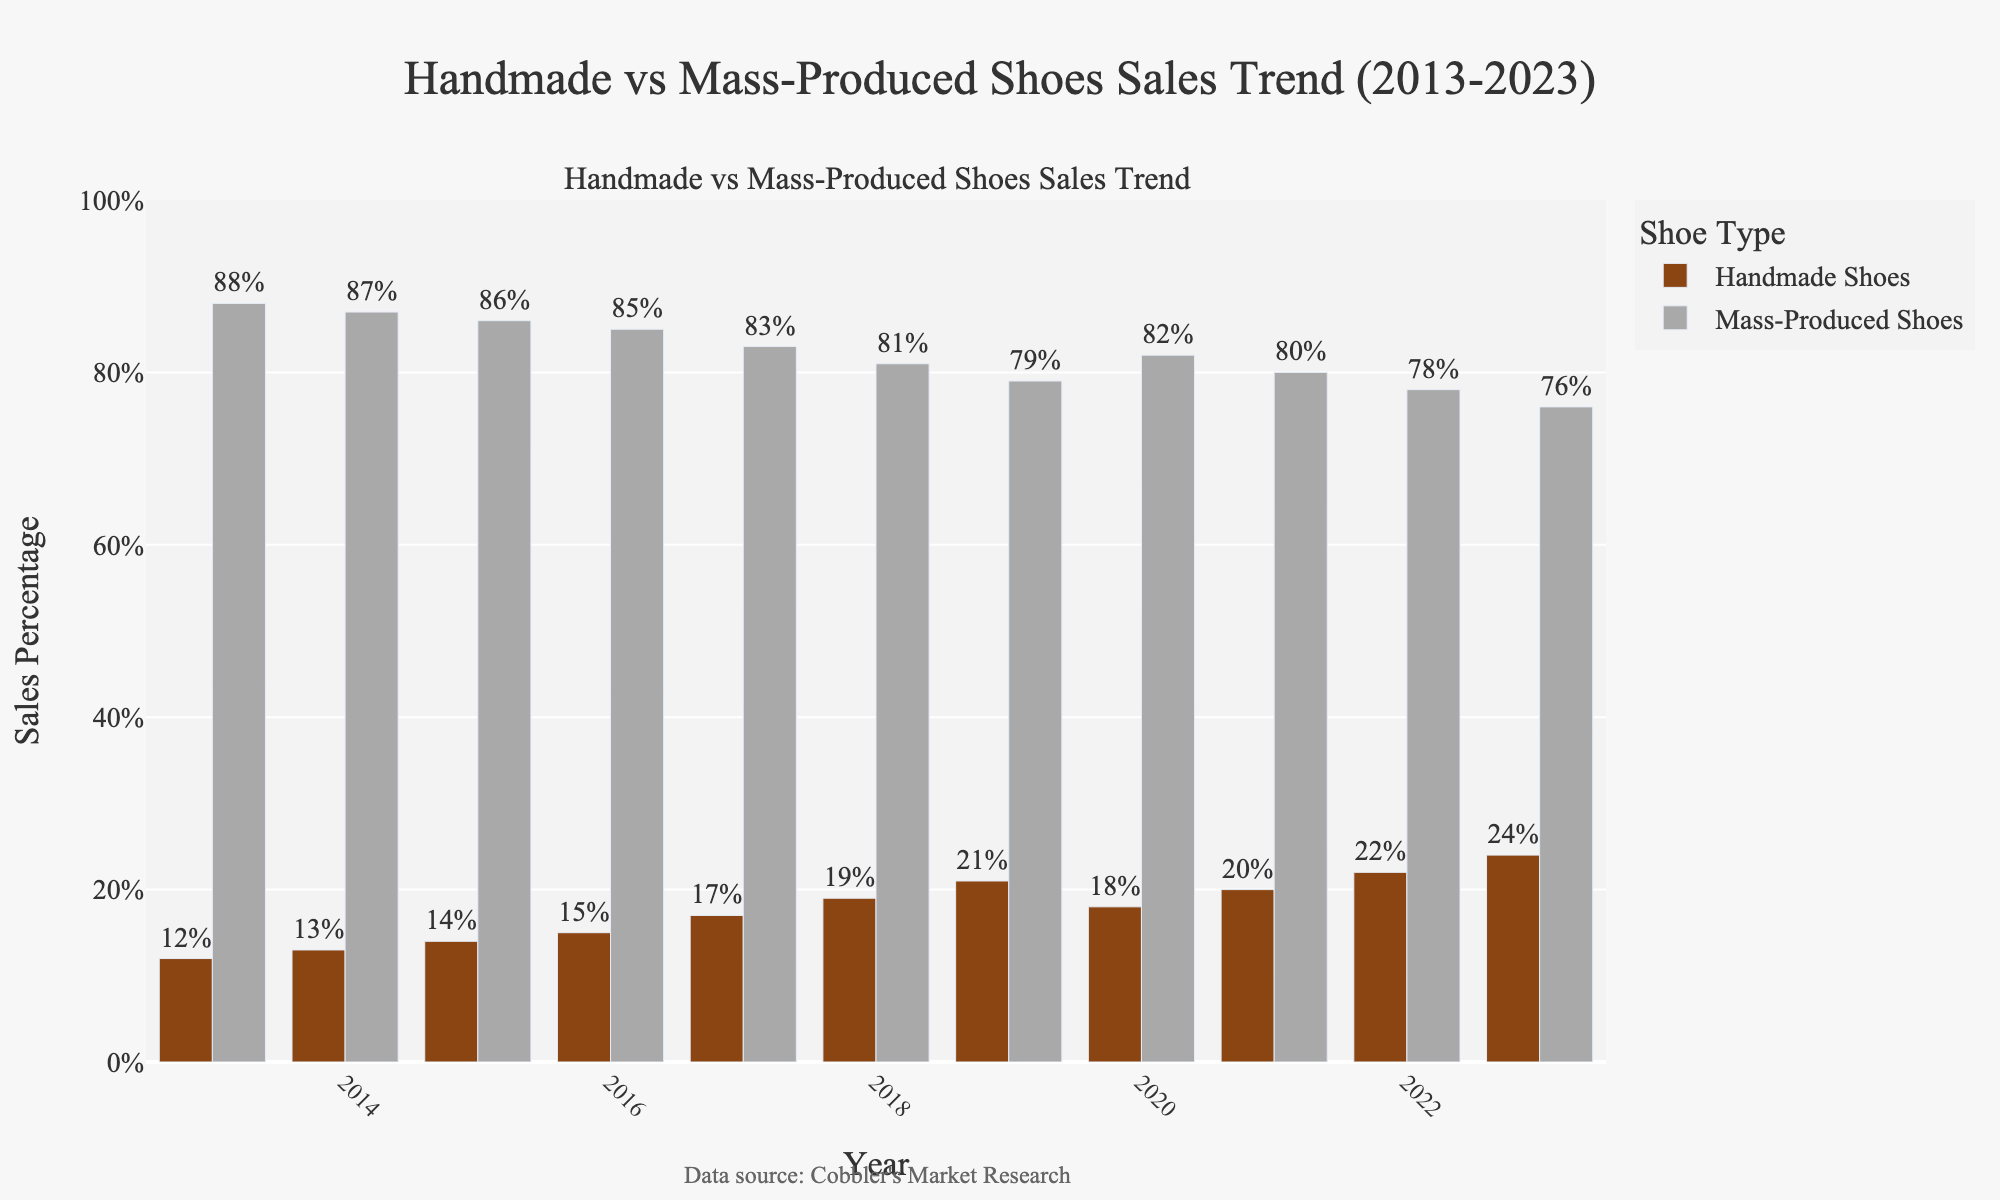Which type of shoes had the higher sales percentage in 2019? The bar representing Mass-Produced Shoes in 2019 is taller than the one for Handmade Shoes. Thus, Mass-Produced Shoes had a higher sales percentage in 2019.
Answer: Mass-Produced Shoes How much did the sales percentage of Handmade Shoes increase from 2013 to 2023? The sales percentage for Handmade Shoes was 12% in 2013 and increased to 24% in 2023. The increase is calculated as 24% - 12% = 12%.
Answer: 12% In which year did Handmade Shoes sales experience a drop? The Handmade Shoes sales dropped between 2019 and 2020 with values changing from 21% in 2019 to 18% in 2020.
Answer: 2020 What is the total sales percentage of both types of shoes in 2021? Adding the sales percentages of Handmade Shoes (20%) and Mass-Produced Shoes (80%) in 2021 results in 20% + 80% = 100%.
Answer: 100% By how many percentage points did the sales percentage of Mass-Produced Shoes decrease from 2013 to 2023? The sales percentage of Mass-Produced Shoes was 88% in 2013 and decreased to 76% in 2023. The decrease is calculated as 88% - 76% = 12%.
Answer: 12% What is the average sales percentage of Handmade Shoes over the decade from 2013 to 2023? Adding the yearly percentages for Handmade Shoes from 2013 to 2023: 12 + 13 + 14 + 15 + 17 + 19 + 21 + 18 + 20 + 22 + 24 = 195. Dividing by the number of years, 195 / 11 ≈ 17.73%.
Answer: ≈ 17.73% Which type of shoes shows a consistent upward trend over the decade? By examining the bars' heights from 2013 to 2023, Handmade Shoes consistently show an upward trend, except for 2020. Mass-Produced Shoes have a downward trend.
Answer: Handmade Shoes Which year had equal sales percentages of Handmade and Mass-Produced Shoes summing up to 100%? Looking at the x-axis labels and adding up the sales percentages of Handmade and Mass-Produced Shoes for each year, all pair sums are 100%. For instance, 2014 combines 13% (Handmade) and 87% (Mass-Produced) to make 100%.
Answer: Every Year 